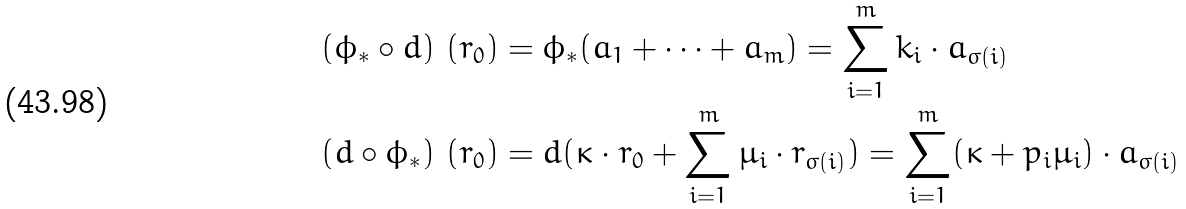<formula> <loc_0><loc_0><loc_500><loc_500>( \phi _ { * } \circ d ) \ ( r _ { 0 } ) & = \phi _ { * } ( a _ { 1 } + \dots + a _ { m } ) = \sum _ { i = 1 } ^ { m } k _ { i } \cdot a _ { \sigma ( i ) } \\ ( d \circ \phi _ { * } ) \ ( r _ { 0 } ) & = d ( \kappa \cdot r _ { 0 } + \sum _ { i = 1 } ^ { m } \mu _ { i } \cdot r _ { \sigma ( i ) } ) = \sum _ { i = 1 } ^ { m } ( \kappa + p _ { i } \mu _ { i } ) \cdot a _ { \sigma ( i ) }</formula> 